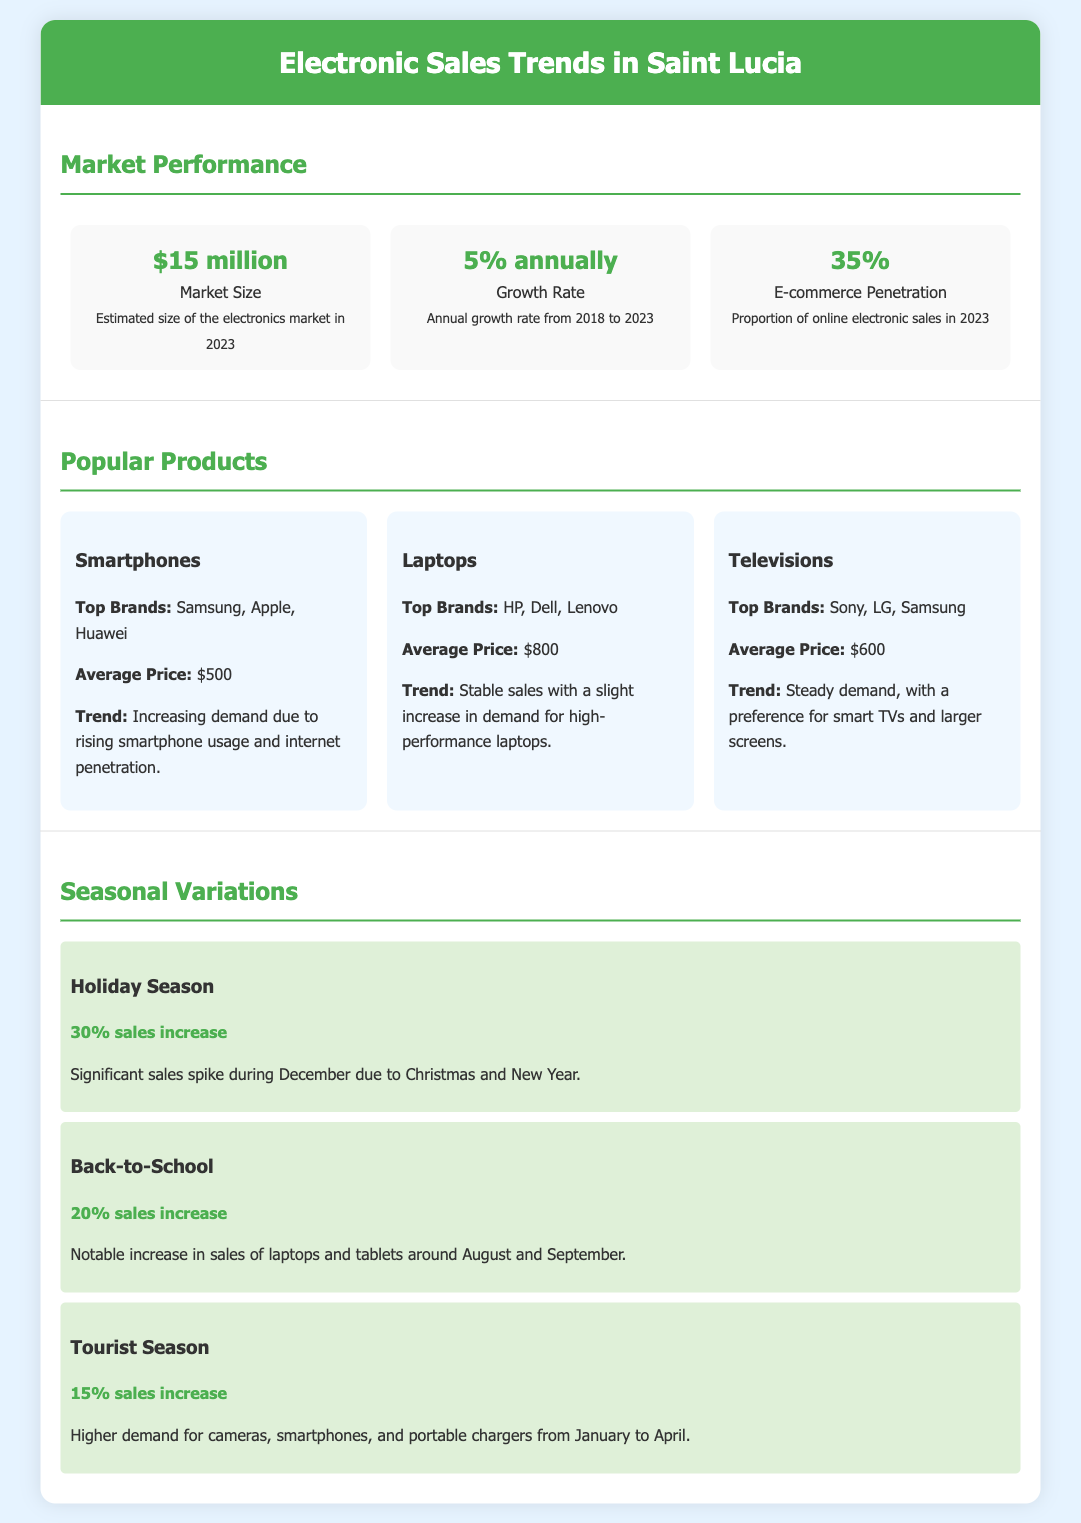what is the estimated size of the electronics market in 2023? The estimated size of the electronics market in 2023 is mentioned as $15 million.
Answer: $15 million what is the annual growth rate from 2018 to 2023? The document states the annual growth rate is 5%.
Answer: 5% annually what percentage of electronic sales are from e-commerce in 2023? The proportion of online electronic sales in 2023 is indicated as 35%.
Answer: 35% which product has an average price of $500? The average price of smartphones is listed as $500.
Answer: $500 what is the sales increase during the Holiday Season? The document states there is a 30% sales increase during the Holiday Season.
Answer: 30% sales increase which brands are top sellers for laptops? HP, Dell, and Lenovo are mentioned as top brands for laptops.
Answer: HP, Dell, Lenovo what trend is observed for televisions? The trend for televisions indicates steady demand with a preference for smart TVs and larger screens.
Answer: Steady demand for smart TVs during which period is the notable increase in sales for laptops and tablets? Sales for laptops and tablets notably increase around August and September.
Answer: August and September how much is the sales increase during the Tourist Season? The sales increase during the Tourist Season is stated as 15%.
Answer: 15% sales increase 